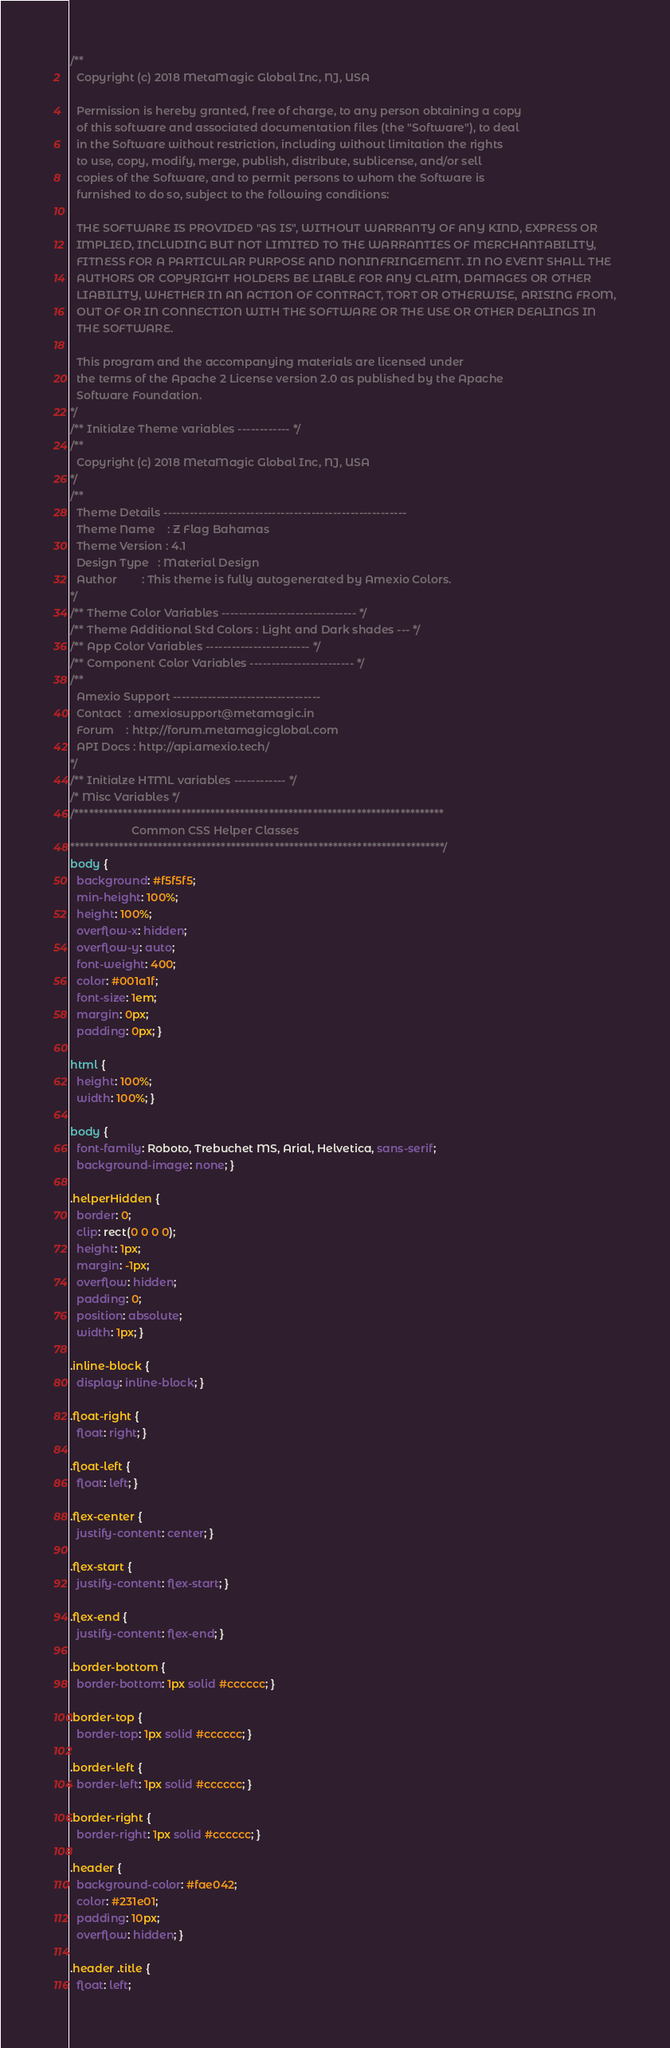Convert code to text. <code><loc_0><loc_0><loc_500><loc_500><_CSS_>/** 
  Copyright (c) 2018 MetaMagic Global Inc, NJ, USA 

  Permission is hereby granted, free of charge, to any person obtaining a copy
  of this software and associated documentation files (the "Software"), to deal
  in the Software without restriction, including without limitation the rights
  to use, copy, modify, merge, publish, distribute, sublicense, and/or sell
  copies of the Software, and to permit persons to whom the Software is
  furnished to do so, subject to the following conditions:

  THE SOFTWARE IS PROVIDED "AS IS", WITHOUT WARRANTY OF ANY KIND, EXPRESS OR
  IMPLIED, INCLUDING BUT NOT LIMITED TO THE WARRANTIES OF MERCHANTABILITY,
  FITNESS FOR A PARTICULAR PURPOSE AND NONINFRINGEMENT. IN NO EVENT SHALL THE
  AUTHORS OR COPYRIGHT HOLDERS BE LIABLE FOR ANY CLAIM, DAMAGES OR OTHER
  LIABILITY, WHETHER IN AN ACTION OF CONTRACT, TORT OR OTHERWISE, ARISING FROM,
  OUT OF OR IN CONNECTION WITH THE SOFTWARE OR THE USE OR OTHER DEALINGS IN
  THE SOFTWARE.

  This program and the accompanying materials are licensed under
  the terms of the Apache 2 License version 2.0 as published by the Apache
  Software Foundation.
*/
/** Initialze Theme variables ------------ */
/** 
  Copyright (c) 2018 MetaMagic Global Inc, NJ, USA 
*/
/**
  Theme Details -------------------------------------------------------- 
  Theme Name    : Z Flag Bahamas
  Theme Version : 4.1
  Design Type   : Material Design
  Author        : This theme is fully autogenerated by Amexio Colors.
*/
/** Theme Color Variables ------------------------------- */
/** Theme Additional Std Colors : Light and Dark shades --- */
/** App Color Variables ------------------------ */
/** Component Color Variables ------------------------ */
/** 
  Amexio Support ---------------------------------- 
  Contact  : amexiosupport@metamagic.in 
  Forum    : http://forum.metamagicglobal.com
  API Docs : http://api.amexio.tech/
*/
/** Initialze HTML variables ------------ */
/* Misc Variables */
/****************************************************************************
                    Common CSS Helper Classes
*****************************************************************************/
body {
  background: #f5f5f5;
  min-height: 100%;
  height: 100%;
  overflow-x: hidden;
  overflow-y: auto;
  font-weight: 400;
  color: #001a1f;
  font-size: 1em;
  margin: 0px;
  padding: 0px; }

html {
  height: 100%;
  width: 100%; }

body {
  font-family: Roboto, Trebuchet MS, Arial, Helvetica, sans-serif;
  background-image: none; }

.helperHidden {
  border: 0;
  clip: rect(0 0 0 0);
  height: 1px;
  margin: -1px;
  overflow: hidden;
  padding: 0;
  position: absolute;
  width: 1px; }

.inline-block {
  display: inline-block; }

.float-right {
  float: right; }

.float-left {
  float: left; }

.flex-center {
  justify-content: center; }

.flex-start {
  justify-content: flex-start; }

.flex-end {
  justify-content: flex-end; }

.border-bottom {
  border-bottom: 1px solid #cccccc; }

.border-top {
  border-top: 1px solid #cccccc; }

.border-left {
  border-left: 1px solid #cccccc; }

.border-right {
  border-right: 1px solid #cccccc; }

.header {
  background-color: #fae042;
  color: #231e01;
  padding: 10px;
  overflow: hidden; }

.header .title {
  float: left;</code> 